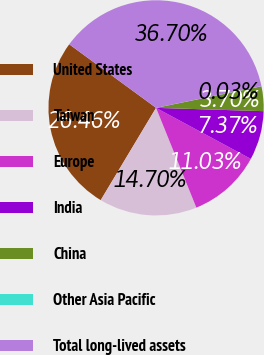Convert chart to OTSL. <chart><loc_0><loc_0><loc_500><loc_500><pie_chart><fcel>United States<fcel>Taiwan<fcel>Europe<fcel>India<fcel>China<fcel>Other Asia Pacific<fcel>Total long-lived assets<nl><fcel>26.46%<fcel>14.7%<fcel>11.03%<fcel>7.37%<fcel>3.7%<fcel>0.03%<fcel>36.7%<nl></chart> 